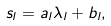<formula> <loc_0><loc_0><loc_500><loc_500>s _ { l } = a _ { l } \lambda _ { l } + b _ { l } ,</formula> 